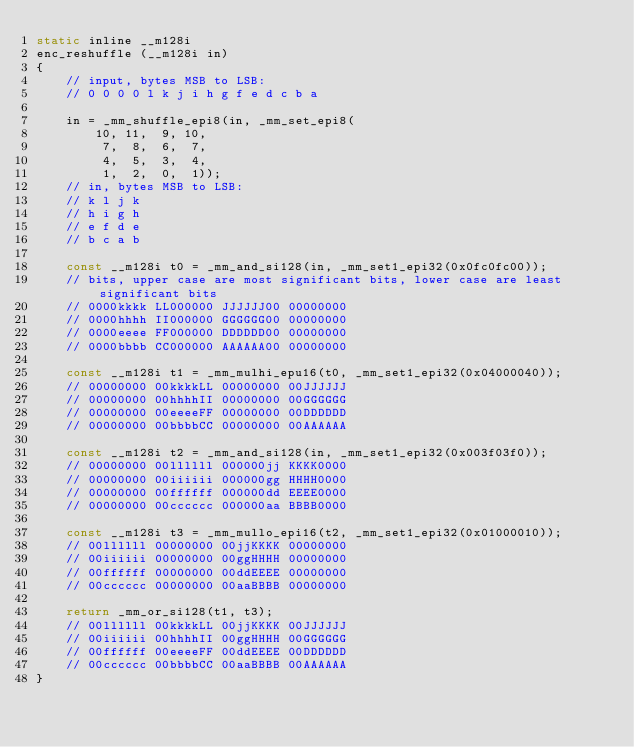Convert code to text. <code><loc_0><loc_0><loc_500><loc_500><_C_>static inline __m128i
enc_reshuffle (__m128i in)
{
	// input, bytes MSB to LSB:
	// 0 0 0 0 l k j i h g f e d c b a

	in = _mm_shuffle_epi8(in, _mm_set_epi8(
		10, 11,  9, 10,
		 7,  8,  6,  7,
		 4,  5,  3,  4,
		 1,  2,  0,  1));
	// in, bytes MSB to LSB:
	// k l j k
	// h i g h
	// e f d e
	// b c a b

	const __m128i t0 = _mm_and_si128(in, _mm_set1_epi32(0x0fc0fc00));
	// bits, upper case are most significant bits, lower case are least significant bits
	// 0000kkkk LL000000 JJJJJJ00 00000000
	// 0000hhhh II000000 GGGGGG00 00000000
	// 0000eeee FF000000 DDDDDD00 00000000
	// 0000bbbb CC000000 AAAAAA00 00000000

	const __m128i t1 = _mm_mulhi_epu16(t0, _mm_set1_epi32(0x04000040));
	// 00000000 00kkkkLL 00000000 00JJJJJJ
	// 00000000 00hhhhII 00000000 00GGGGGG
	// 00000000 00eeeeFF 00000000 00DDDDDD
	// 00000000 00bbbbCC 00000000 00AAAAAA

	const __m128i t2 = _mm_and_si128(in, _mm_set1_epi32(0x003f03f0));
	// 00000000 00llllll 000000jj KKKK0000
	// 00000000 00iiiiii 000000gg HHHH0000
	// 00000000 00ffffff 000000dd EEEE0000
	// 00000000 00cccccc 000000aa BBBB0000

	const __m128i t3 = _mm_mullo_epi16(t2, _mm_set1_epi32(0x01000010));
	// 00llllll 00000000 00jjKKKK 00000000
	// 00iiiiii 00000000 00ggHHHH 00000000
	// 00ffffff 00000000 00ddEEEE 00000000
	// 00cccccc 00000000 00aaBBBB 00000000

	return _mm_or_si128(t1, t3);
	// 00llllll 00kkkkLL 00jjKKKK 00JJJJJJ
	// 00iiiiii 00hhhhII 00ggHHHH 00GGGGGG
	// 00ffffff 00eeeeFF 00ddEEEE 00DDDDDD
	// 00cccccc 00bbbbCC 00aaBBBB 00AAAAAA
}
</code> 